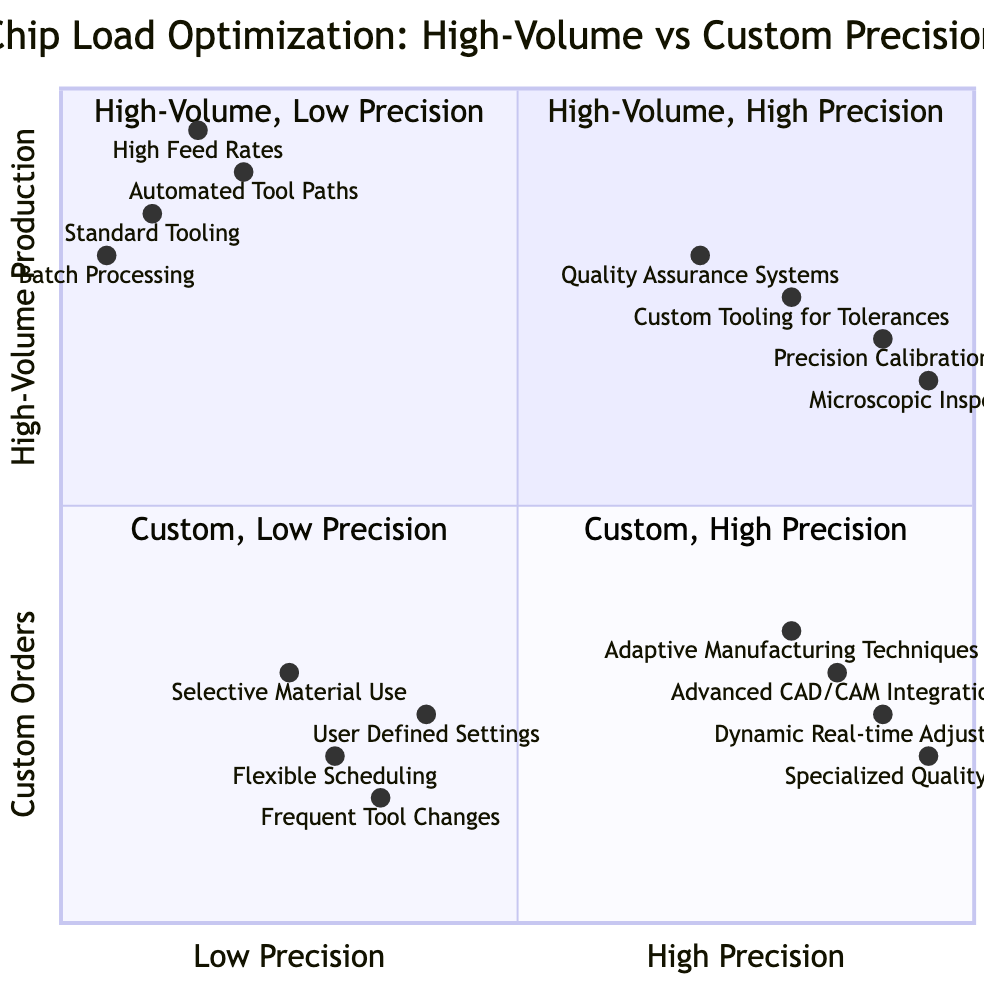What are the elements listed in the "High-Volume Production (High Precision)" quadrant? This quadrant contains four elements: Quality Assurance Systems, Custom Tooling for Tolerances, Precision Calibration, and Microscopic Inspection.
Answer: Quality Assurance Systems, Custom Tooling for Tolerances, Precision Calibration, Microscopic Inspection How many elements are in the "Custom Orders (Low Precision)" quadrant? The quadrant includes four elements: Flexible Scheduling, User Defined Settings, Frequent Tool Changes, and Selective Material Use, totaling four elements.
Answer: 4 Which element in the "High-Volume Production (Low Precision)" quadrant has the highest feed rate? High Feed Rates is listed in this quadrant and is known for optimized high feed rates to maximize material removal.
Answer: High Feed Rates What is the description of the element "Adaptive Manufacturing Techniques"? This element is part of the "Custom Orders (High Precision)" quadrant and is described as employing adaptive techniques to handle variation in custom orders.
Answer: Employment of adaptive techniques to handle variation in custom orders Which quadrant contains the element "Dynamic Real-time Adjustments"? This element is found in the "Custom Orders (High Precision)" quadrant, focusing on real-time monitoring and adjustments.
Answer: Custom Orders (High Precision) What is the primary difference between the "High-Volume Production (Low Precision)" and "Custom Orders (Low Precision)" quadrants? The primary difference lies in the focus; High-Volume Production (Low Precision) is centered around efficiency methods, while Custom Orders (Low Precision) emphasizes customization and flexibility in settings.
Answer: Focus on efficiency vs. customization Which element has the highest performance rating within the "Custom Orders (High Precision)" quadrant? The element with the highest performance rating is Specialized Quality Control, which emphasizes detailed and stringent quality processes for each order.
Answer: Specialized Quality Control Comparing "Standard Tooling" and "Custom Tooling for Tolerances", which has a higher focus on precision? Custom Tooling for Tolerances specifically targets tight tolerances, while Standard Tooling is more about standardization, indicating that Custom Tooling for Tolerances has a higher focus on precision.
Answer: Custom Tooling for Tolerances How does the implementation of Automated Tool Paths impact production efficiency? Automated Tool Paths are implemented to provide pre-defined, repeatable tool paths that significantly enhance process efficiency, especially in high-volume scenarios.
Answer: Increase process efficiency 